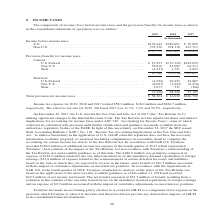From Teradyne's financial document, What are the types of provision (benefit) for income taxes? The document shows two values: Current and Deferred. From the document: "Provision (benefit) for income taxes Current: U.S. Federal . $ 19,297 $ (59,122) $162,679 Non-U.S. . 52,810 45,083 64,313 State . (4,347) 1,721 Deferr..." Also, What are the components under Current provision (benefit) for income taxes? The document contains multiple relevant values: U.S. Federal, Non-U.S, State. From the document: "re income taxes U.S. . $192,442 $189,691 $ 76,699 Non-U.S. . 333,330 278,110 447,713 (59,122) $162,679 Non-U.S. . 52,810 45,083 64,313 State . (4,347)..." Also, What does the table show? The components of income (loss) before income taxes and the provision (benefit) for income taxes as shown in the consolidated statements of operations. The document states: "The components of income (loss) before income taxes and the provision (benefit) for income taxes as shown in the consolidated statements of operations..." Additionally, Which year was the amount of income before taxes the largest? According to the financial document, 2019. The relevant text states: "2019 2018 2017..." Also, can you calculate: What was the change in U.S. Income before income taxes in 2019 from 2018? Based on the calculation: 192,442-189,691, the result is 2751 (in thousands). This is based on the information: "(in thousands) Income before income taxes U.S. . $192,442 $189,691 $ 76,699 Non-U.S. . 333,330 278,110 447,713 ands) Income before income taxes U.S. . $192,442 $189,691 $ 76,699 Non-U.S. . 333,330 278..." The key data points involved are: 189,691, 192,442. Also, can you calculate: What was the percentage change in U.S. Income before income taxes in 2019 from 2018? To answer this question, I need to perform calculations using the financial data. The calculation is: (192,442-189,691)/189,691, which equals 1.45 (percentage). This is based on the information: "(in thousands) Income before income taxes U.S. . $192,442 $189,691 $ 76,699 Non-U.S. . 333,330 278,110 447,713 ands) Income before income taxes U.S. . $192,442 $189,691 $ 76,699 Non-U.S. . 333,330 278..." The key data points involved are: 189,691, 192,442. 